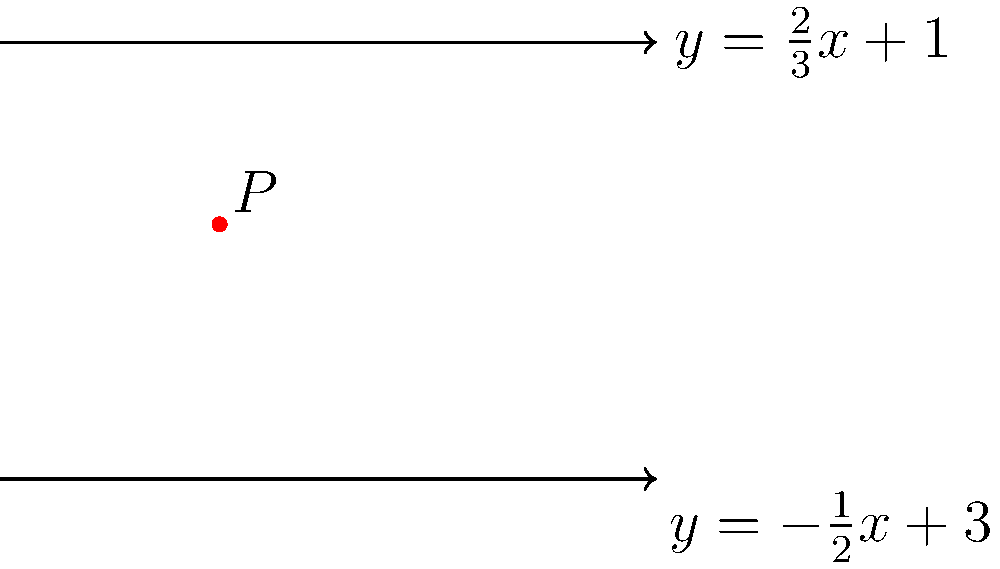Two lines are given by the equations $y = \frac{2}{3}x + 1$ and $y = -\frac{1}{2}x + 3$. Find the coordinates of the point $P$ where these lines intersect. How does this demonstrate the concrete nature of geometric relationships? To find the intersection point, we need to solve the system of equations:

1) $y = \frac{2}{3}x + 1$
2) $y = -\frac{1}{2}x + 3$

Step 1: Set the equations equal to each other.
$\frac{2}{3}x + 1 = -\frac{1}{2}x + 3$

Step 2: Solve for x.
$\frac{2}{3}x + \frac{1}{2}x = 3 - 1$
$\frac{2}{3}x + \frac{1}{2}x = 2$
$\frac{4}{6}x + \frac{3}{6}x = 2$
$\frac{7}{6}x = 2$
$x = \frac{12}{7} = 1.714285714$

Step 3: Substitute this x-value into either of the original equations to find y.
Using $y = \frac{2}{3}x + 1$:
$y = \frac{2}{3}(1.714285714) + 1$
$y = 1.142857143 + 1 = 2.142857143$

Step 4: Round to two decimal places for practicality.
$P(1.71, 2.14)$

This demonstrates the concrete nature of geometric relationships because:

1) The intersection point is a unique, precisely defined location in space.
2) It can be calculated using straightforward algebraic methods.
3) The result is objective and verifiable, not subject to interpretation.
4) The graphical representation provides a clear visual confirmation of the algebraic solution.
Answer: $P(1.71, 2.14)$ 